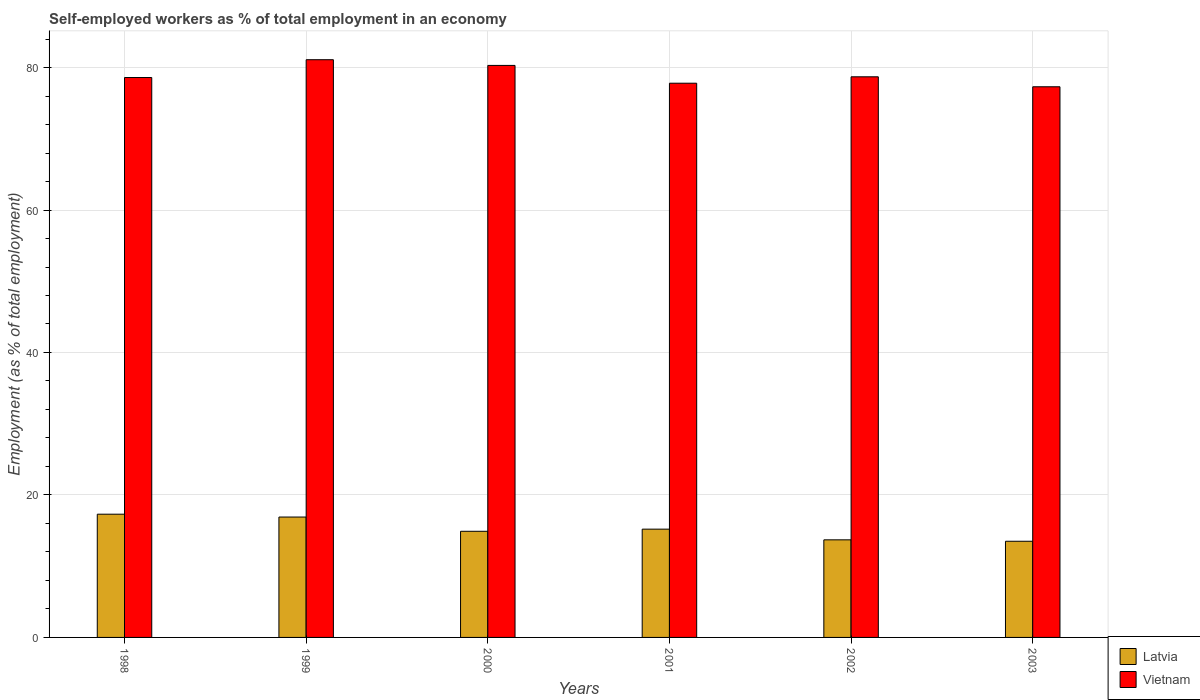How many different coloured bars are there?
Your response must be concise. 2. Are the number of bars per tick equal to the number of legend labels?
Your answer should be very brief. Yes. Are the number of bars on each tick of the X-axis equal?
Offer a terse response. Yes. How many bars are there on the 2nd tick from the left?
Make the answer very short. 2. What is the percentage of self-employed workers in Vietnam in 2002?
Your answer should be very brief. 78.7. Across all years, what is the maximum percentage of self-employed workers in Vietnam?
Your answer should be very brief. 81.1. In which year was the percentage of self-employed workers in Vietnam maximum?
Keep it short and to the point. 1999. In which year was the percentage of self-employed workers in Latvia minimum?
Provide a succinct answer. 2003. What is the total percentage of self-employed workers in Latvia in the graph?
Ensure brevity in your answer.  91.5. What is the difference between the percentage of self-employed workers in Latvia in 2000 and that in 2003?
Give a very brief answer. 1.4. What is the difference between the percentage of self-employed workers in Vietnam in 2000 and the percentage of self-employed workers in Latvia in 2003?
Offer a very short reply. 66.8. What is the average percentage of self-employed workers in Latvia per year?
Offer a terse response. 15.25. In the year 1998, what is the difference between the percentage of self-employed workers in Vietnam and percentage of self-employed workers in Latvia?
Your answer should be compact. 61.3. In how many years, is the percentage of self-employed workers in Latvia greater than 12 %?
Give a very brief answer. 6. What is the ratio of the percentage of self-employed workers in Latvia in 1999 to that in 2001?
Provide a succinct answer. 1.11. Is the percentage of self-employed workers in Vietnam in 2000 less than that in 2003?
Provide a succinct answer. No. Is the difference between the percentage of self-employed workers in Vietnam in 1999 and 2002 greater than the difference between the percentage of self-employed workers in Latvia in 1999 and 2002?
Offer a very short reply. No. What is the difference between the highest and the second highest percentage of self-employed workers in Vietnam?
Offer a very short reply. 0.8. What is the difference between the highest and the lowest percentage of self-employed workers in Latvia?
Your answer should be very brief. 3.8. In how many years, is the percentage of self-employed workers in Latvia greater than the average percentage of self-employed workers in Latvia taken over all years?
Give a very brief answer. 2. What does the 1st bar from the left in 1998 represents?
Offer a terse response. Latvia. What does the 2nd bar from the right in 2002 represents?
Your answer should be compact. Latvia. How many bars are there?
Your answer should be very brief. 12. Are all the bars in the graph horizontal?
Keep it short and to the point. No. How many years are there in the graph?
Offer a terse response. 6. What is the difference between two consecutive major ticks on the Y-axis?
Your answer should be very brief. 20. Does the graph contain any zero values?
Your answer should be compact. No. Does the graph contain grids?
Your response must be concise. Yes. How many legend labels are there?
Make the answer very short. 2. How are the legend labels stacked?
Your answer should be very brief. Vertical. What is the title of the graph?
Offer a terse response. Self-employed workers as % of total employment in an economy. What is the label or title of the X-axis?
Keep it short and to the point. Years. What is the label or title of the Y-axis?
Make the answer very short. Employment (as % of total employment). What is the Employment (as % of total employment) in Latvia in 1998?
Your answer should be compact. 17.3. What is the Employment (as % of total employment) in Vietnam in 1998?
Your response must be concise. 78.6. What is the Employment (as % of total employment) in Latvia in 1999?
Give a very brief answer. 16.9. What is the Employment (as % of total employment) in Vietnam in 1999?
Provide a succinct answer. 81.1. What is the Employment (as % of total employment) in Latvia in 2000?
Make the answer very short. 14.9. What is the Employment (as % of total employment) in Vietnam in 2000?
Ensure brevity in your answer.  80.3. What is the Employment (as % of total employment) of Latvia in 2001?
Give a very brief answer. 15.2. What is the Employment (as % of total employment) in Vietnam in 2001?
Make the answer very short. 77.8. What is the Employment (as % of total employment) in Latvia in 2002?
Provide a succinct answer. 13.7. What is the Employment (as % of total employment) of Vietnam in 2002?
Provide a short and direct response. 78.7. What is the Employment (as % of total employment) in Latvia in 2003?
Offer a very short reply. 13.5. What is the Employment (as % of total employment) in Vietnam in 2003?
Your response must be concise. 77.3. Across all years, what is the maximum Employment (as % of total employment) of Latvia?
Ensure brevity in your answer.  17.3. Across all years, what is the maximum Employment (as % of total employment) in Vietnam?
Offer a very short reply. 81.1. Across all years, what is the minimum Employment (as % of total employment) in Vietnam?
Offer a terse response. 77.3. What is the total Employment (as % of total employment) in Latvia in the graph?
Offer a terse response. 91.5. What is the total Employment (as % of total employment) of Vietnam in the graph?
Provide a short and direct response. 473.8. What is the difference between the Employment (as % of total employment) of Latvia in 1998 and that in 1999?
Offer a terse response. 0.4. What is the difference between the Employment (as % of total employment) of Latvia in 1998 and that in 2000?
Make the answer very short. 2.4. What is the difference between the Employment (as % of total employment) in Vietnam in 1998 and that in 2001?
Provide a short and direct response. 0.8. What is the difference between the Employment (as % of total employment) of Latvia in 1998 and that in 2002?
Keep it short and to the point. 3.6. What is the difference between the Employment (as % of total employment) of Vietnam in 1998 and that in 2003?
Ensure brevity in your answer.  1.3. What is the difference between the Employment (as % of total employment) in Latvia in 1999 and that in 2000?
Ensure brevity in your answer.  2. What is the difference between the Employment (as % of total employment) of Vietnam in 1999 and that in 2000?
Make the answer very short. 0.8. What is the difference between the Employment (as % of total employment) in Vietnam in 1999 and that in 2002?
Keep it short and to the point. 2.4. What is the difference between the Employment (as % of total employment) in Latvia in 1999 and that in 2003?
Your answer should be compact. 3.4. What is the difference between the Employment (as % of total employment) in Vietnam in 1999 and that in 2003?
Make the answer very short. 3.8. What is the difference between the Employment (as % of total employment) in Latvia in 2000 and that in 2001?
Your response must be concise. -0.3. What is the difference between the Employment (as % of total employment) in Vietnam in 2000 and that in 2001?
Make the answer very short. 2.5. What is the difference between the Employment (as % of total employment) in Latvia in 2000 and that in 2002?
Give a very brief answer. 1.2. What is the difference between the Employment (as % of total employment) in Vietnam in 2000 and that in 2002?
Your answer should be compact. 1.6. What is the difference between the Employment (as % of total employment) of Latvia in 2000 and that in 2003?
Provide a short and direct response. 1.4. What is the difference between the Employment (as % of total employment) in Vietnam in 2001 and that in 2002?
Offer a very short reply. -0.9. What is the difference between the Employment (as % of total employment) of Latvia in 2001 and that in 2003?
Your response must be concise. 1.7. What is the difference between the Employment (as % of total employment) in Vietnam in 2001 and that in 2003?
Make the answer very short. 0.5. What is the difference between the Employment (as % of total employment) in Latvia in 2002 and that in 2003?
Provide a short and direct response. 0.2. What is the difference between the Employment (as % of total employment) in Latvia in 1998 and the Employment (as % of total employment) in Vietnam in 1999?
Keep it short and to the point. -63.8. What is the difference between the Employment (as % of total employment) of Latvia in 1998 and the Employment (as % of total employment) of Vietnam in 2000?
Provide a short and direct response. -63. What is the difference between the Employment (as % of total employment) in Latvia in 1998 and the Employment (as % of total employment) in Vietnam in 2001?
Provide a short and direct response. -60.5. What is the difference between the Employment (as % of total employment) of Latvia in 1998 and the Employment (as % of total employment) of Vietnam in 2002?
Provide a short and direct response. -61.4. What is the difference between the Employment (as % of total employment) in Latvia in 1998 and the Employment (as % of total employment) in Vietnam in 2003?
Keep it short and to the point. -60. What is the difference between the Employment (as % of total employment) in Latvia in 1999 and the Employment (as % of total employment) in Vietnam in 2000?
Your answer should be very brief. -63.4. What is the difference between the Employment (as % of total employment) of Latvia in 1999 and the Employment (as % of total employment) of Vietnam in 2001?
Offer a very short reply. -60.9. What is the difference between the Employment (as % of total employment) in Latvia in 1999 and the Employment (as % of total employment) in Vietnam in 2002?
Your response must be concise. -61.8. What is the difference between the Employment (as % of total employment) of Latvia in 1999 and the Employment (as % of total employment) of Vietnam in 2003?
Provide a succinct answer. -60.4. What is the difference between the Employment (as % of total employment) in Latvia in 2000 and the Employment (as % of total employment) in Vietnam in 2001?
Give a very brief answer. -62.9. What is the difference between the Employment (as % of total employment) in Latvia in 2000 and the Employment (as % of total employment) in Vietnam in 2002?
Offer a terse response. -63.8. What is the difference between the Employment (as % of total employment) of Latvia in 2000 and the Employment (as % of total employment) of Vietnam in 2003?
Provide a short and direct response. -62.4. What is the difference between the Employment (as % of total employment) in Latvia in 2001 and the Employment (as % of total employment) in Vietnam in 2002?
Offer a very short reply. -63.5. What is the difference between the Employment (as % of total employment) of Latvia in 2001 and the Employment (as % of total employment) of Vietnam in 2003?
Offer a very short reply. -62.1. What is the difference between the Employment (as % of total employment) in Latvia in 2002 and the Employment (as % of total employment) in Vietnam in 2003?
Provide a succinct answer. -63.6. What is the average Employment (as % of total employment) of Latvia per year?
Your answer should be very brief. 15.25. What is the average Employment (as % of total employment) in Vietnam per year?
Ensure brevity in your answer.  78.97. In the year 1998, what is the difference between the Employment (as % of total employment) of Latvia and Employment (as % of total employment) of Vietnam?
Ensure brevity in your answer.  -61.3. In the year 1999, what is the difference between the Employment (as % of total employment) of Latvia and Employment (as % of total employment) of Vietnam?
Keep it short and to the point. -64.2. In the year 2000, what is the difference between the Employment (as % of total employment) in Latvia and Employment (as % of total employment) in Vietnam?
Give a very brief answer. -65.4. In the year 2001, what is the difference between the Employment (as % of total employment) in Latvia and Employment (as % of total employment) in Vietnam?
Your answer should be very brief. -62.6. In the year 2002, what is the difference between the Employment (as % of total employment) in Latvia and Employment (as % of total employment) in Vietnam?
Your response must be concise. -65. In the year 2003, what is the difference between the Employment (as % of total employment) of Latvia and Employment (as % of total employment) of Vietnam?
Offer a very short reply. -63.8. What is the ratio of the Employment (as % of total employment) of Latvia in 1998 to that in 1999?
Your answer should be compact. 1.02. What is the ratio of the Employment (as % of total employment) of Vietnam in 1998 to that in 1999?
Your response must be concise. 0.97. What is the ratio of the Employment (as % of total employment) in Latvia in 1998 to that in 2000?
Make the answer very short. 1.16. What is the ratio of the Employment (as % of total employment) of Vietnam in 1998 to that in 2000?
Your response must be concise. 0.98. What is the ratio of the Employment (as % of total employment) in Latvia in 1998 to that in 2001?
Your answer should be compact. 1.14. What is the ratio of the Employment (as % of total employment) in Vietnam in 1998 to that in 2001?
Your answer should be very brief. 1.01. What is the ratio of the Employment (as % of total employment) in Latvia in 1998 to that in 2002?
Provide a short and direct response. 1.26. What is the ratio of the Employment (as % of total employment) of Vietnam in 1998 to that in 2002?
Make the answer very short. 1. What is the ratio of the Employment (as % of total employment) in Latvia in 1998 to that in 2003?
Your answer should be very brief. 1.28. What is the ratio of the Employment (as % of total employment) in Vietnam in 1998 to that in 2003?
Offer a very short reply. 1.02. What is the ratio of the Employment (as % of total employment) of Latvia in 1999 to that in 2000?
Your answer should be very brief. 1.13. What is the ratio of the Employment (as % of total employment) in Vietnam in 1999 to that in 2000?
Offer a terse response. 1.01. What is the ratio of the Employment (as % of total employment) in Latvia in 1999 to that in 2001?
Offer a terse response. 1.11. What is the ratio of the Employment (as % of total employment) in Vietnam in 1999 to that in 2001?
Ensure brevity in your answer.  1.04. What is the ratio of the Employment (as % of total employment) of Latvia in 1999 to that in 2002?
Provide a short and direct response. 1.23. What is the ratio of the Employment (as % of total employment) in Vietnam in 1999 to that in 2002?
Offer a very short reply. 1.03. What is the ratio of the Employment (as % of total employment) of Latvia in 1999 to that in 2003?
Provide a short and direct response. 1.25. What is the ratio of the Employment (as % of total employment) of Vietnam in 1999 to that in 2003?
Ensure brevity in your answer.  1.05. What is the ratio of the Employment (as % of total employment) of Latvia in 2000 to that in 2001?
Offer a very short reply. 0.98. What is the ratio of the Employment (as % of total employment) of Vietnam in 2000 to that in 2001?
Make the answer very short. 1.03. What is the ratio of the Employment (as % of total employment) of Latvia in 2000 to that in 2002?
Your answer should be very brief. 1.09. What is the ratio of the Employment (as % of total employment) of Vietnam in 2000 to that in 2002?
Your answer should be compact. 1.02. What is the ratio of the Employment (as % of total employment) of Latvia in 2000 to that in 2003?
Your answer should be compact. 1.1. What is the ratio of the Employment (as % of total employment) in Vietnam in 2000 to that in 2003?
Your answer should be compact. 1.04. What is the ratio of the Employment (as % of total employment) in Latvia in 2001 to that in 2002?
Provide a succinct answer. 1.11. What is the ratio of the Employment (as % of total employment) in Latvia in 2001 to that in 2003?
Your answer should be compact. 1.13. What is the ratio of the Employment (as % of total employment) in Vietnam in 2001 to that in 2003?
Keep it short and to the point. 1.01. What is the ratio of the Employment (as % of total employment) in Latvia in 2002 to that in 2003?
Give a very brief answer. 1.01. What is the ratio of the Employment (as % of total employment) in Vietnam in 2002 to that in 2003?
Your answer should be compact. 1.02. What is the difference between the highest and the second highest Employment (as % of total employment) in Latvia?
Provide a short and direct response. 0.4. What is the difference between the highest and the lowest Employment (as % of total employment) of Latvia?
Offer a terse response. 3.8. What is the difference between the highest and the lowest Employment (as % of total employment) in Vietnam?
Your answer should be compact. 3.8. 